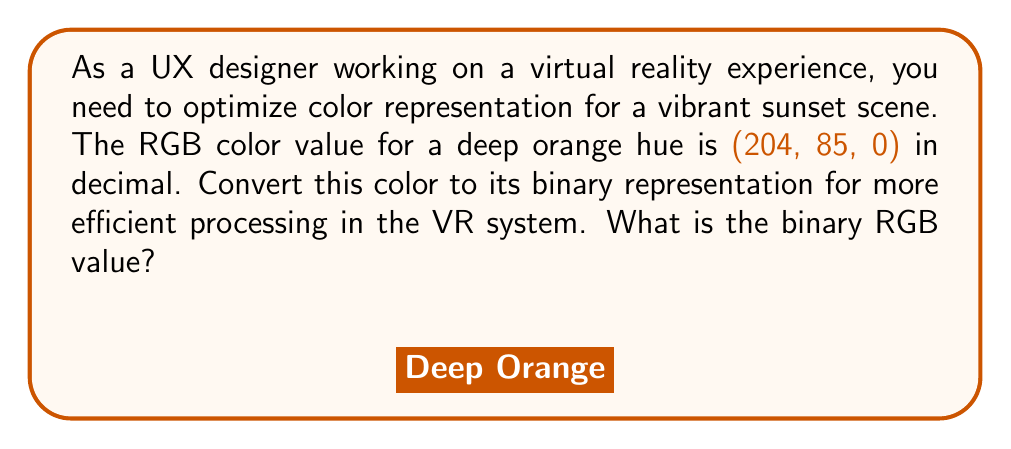Can you answer this question? To convert the decimal RGB values to binary, we need to convert each component separately:

1. Red (204):
   $204_{10} = (11001100)_2$
   
   Calculation:
   $$\begin{aligned}
   204 \div 2 &= 102 \text{ remainder } 0 \\
   102 \div 2 &= 51 \text{ remainder } 0 \\
   51 \div 2 &= 25 \text{ remainder } 1 \\
   25 \div 2 &= 12 \text{ remainder } 1 \\
   12 \div 2 &= 6 \text{ remainder } 0 \\
   6 \div 2 &= 3 \text{ remainder } 0 \\
   3 \div 2 &= 1 \text{ remainder } 1 \\
   1 \div 2 &= 0 \text{ remainder } 1
   \end{aligned}$$

2. Green (85):
   $85_{10} = (01010101)_2$
   
   Calculation:
   $$\begin{aligned}
   85 \div 2 &= 42 \text{ remainder } 1 \\
   42 \div 2 &= 21 \text{ remainder } 0 \\
   21 \div 2 &= 10 \text{ remainder } 1 \\
   10 \div 2 &= 5 \text{ remainder } 0 \\
   5 \div 2 &= 2 \text{ remainder } 1 \\
   2 \div 2 &= 1 \text{ remainder } 0 \\
   1 \div 2 &= 0 \text{ remainder } 1
   \end{aligned}$$

3. Blue (0):
   $0_{10} = (00000000)_2$

Combining these binary values gives us the final RGB representation in binary.
Answer: (11001100, 01010101, 00000000) 